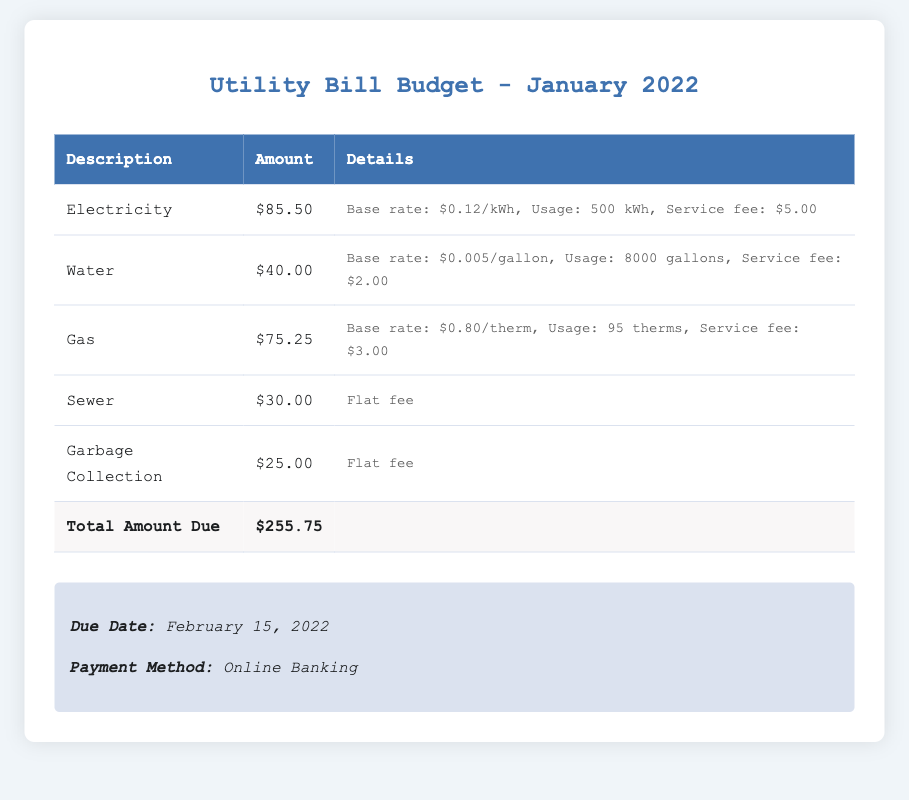What is the total amount due? The total amount due is calculated by summing all individual charges listed in the document, resulting in $255.75.
Answer: $255.75 What is the due date for the payment? The document states that the due date for the payment is provided in the note section, which is February 15, 2022.
Answer: February 15, 2022 How much is charged for electricity? The electricity charge is specifically listed in the table under the description 'Electricity' with an amount of $85.50.
Answer: $85.50 What is the service fee for the water bill? The details under the water charge indicate a service fee of $2.00, which is needed to answer this question.
Answer: $2.00 How many gallons of water were used? According to the water bill details, the usage recorded is 8000 gallons, which is necessary for the answer.
Answer: 8000 gallons What is the base rate for gas per therm? The gas bill specifies that the base rate is $0.80/therm, which provides the answer to the question.
Answer: $0.80/therm What is the charge for garbage collection? The amount for garbage collection is clearly marked in the table as $25.00 under the description 'Garbage Collection'.
Answer: $25.00 What is the base rate for electricity in kWh? The electricity details state that the base rate is $0.12/kWh, which answers the question about electricity rates.
Answer: $0.12/kWh How much was charged for sewer service? The sewer service is noted to have a flat fee, listed as $30.00 in the table under sewer.
Answer: $30.00 